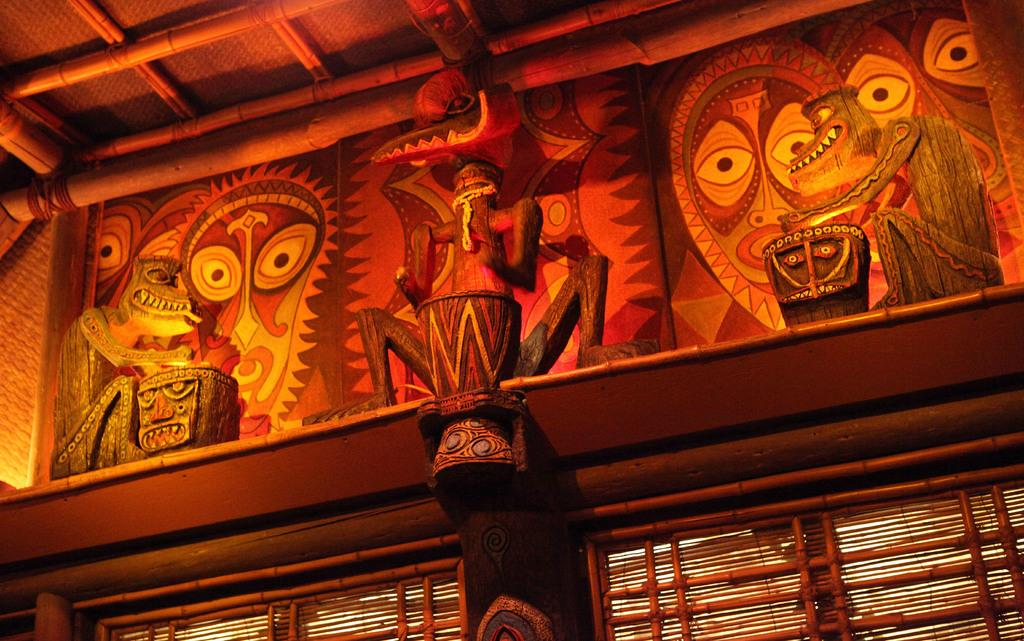What type of objects can be seen in the image? There are statues in the image. What is on the wall behind the statues? There are paintings on the wall behind the statues. What type of window treatment is present in the image? There are window shades in the image. What type of drain can be seen in the image? There is no drain present in the image. What type of celery is depicted in the paintings on the wall? The paintings on the wall do not depict celery; they are of other subjects. 